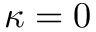<formula> <loc_0><loc_0><loc_500><loc_500>\kappa = 0</formula> 